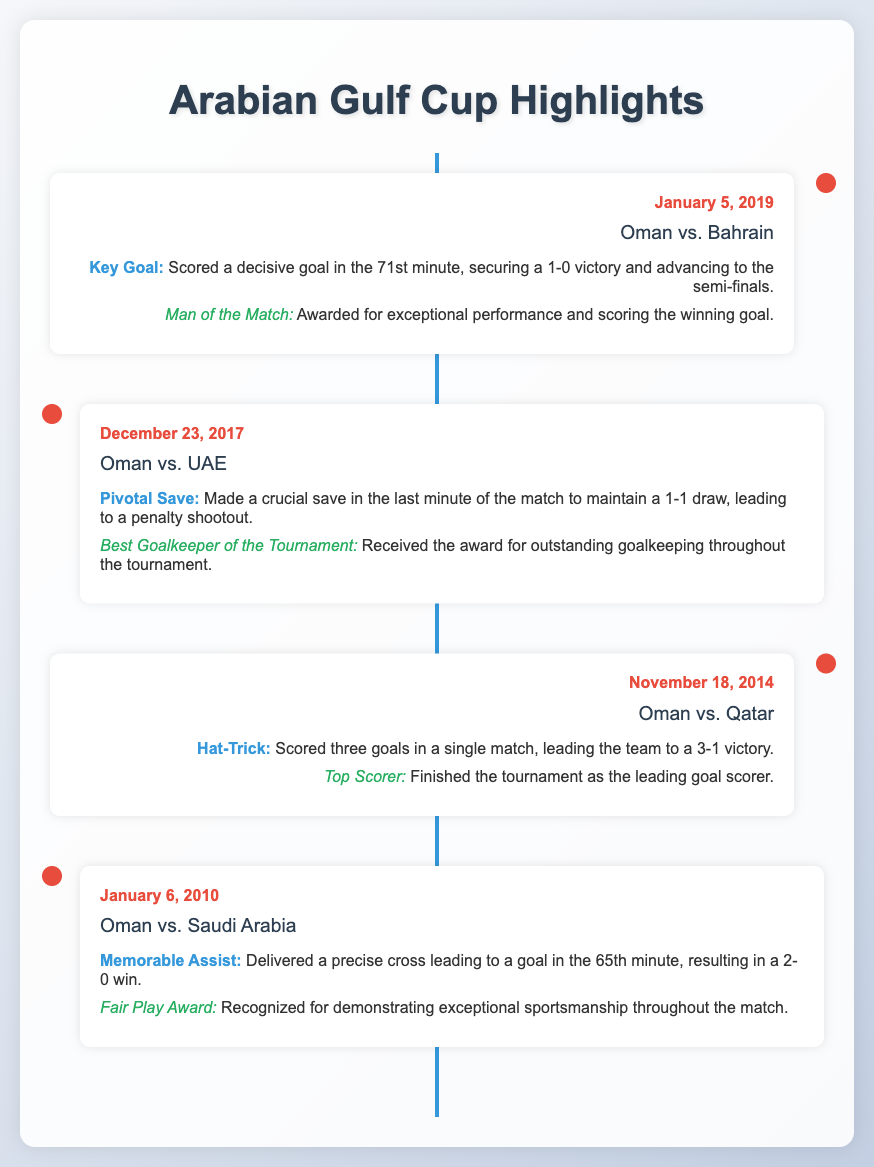What match did Oman play against Bahrain in 2019? The document states that Oman played against Bahrain on January 5, 2019.
Answer: Bahrain What significant event occurred in the Oman vs. UAE match on December 23, 2017? The document highlights that a crucial save was made in the last minute to maintain a 1-1 draw.
Answer: Crucial save When did Oman defeat Qatar with a hat-trick performance? The document mentions the date of this event as November 18, 2014.
Answer: November 18, 2014 Which award was received for the performance in the tournament on December 23, 2017? The document indicates the award for outstanding goalkeeping received during that tournament.
Answer: Best Goalkeeper of the Tournament What was the score of the Oman vs. Saudi Arabia match on January 6, 2010? The match concluded with Oman winning by a score of 2-0.
Answer: 2-0 How many goals were scored in total by the player in the match against Qatar? The document states that the player scored three goals during that match.
Answer: Three Which opponent did Oman face when a decisive goal was scored in the 71st minute? This decisive goal was scored during the match against Bahrain on January 5, 2019.
Answer: Bahrain What recognition did the player receive in the January 6, 2010 match against Saudi Arabia? The player was recognized for demonstrating exceptional sportsmanship.
Answer: Fair Play Award 